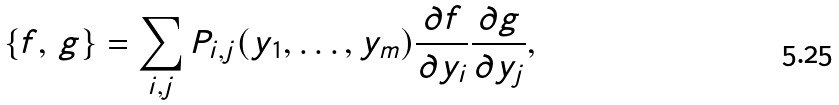Convert formula to latex. <formula><loc_0><loc_0><loc_500><loc_500>\{ f , \, g \} = \sum _ { i , j } P _ { i , j } ( y _ { 1 } , \dots , y _ { m } ) \frac { \partial f } { \partial y _ { i } } \frac { \partial g } { \partial y _ { j } } ,</formula> 